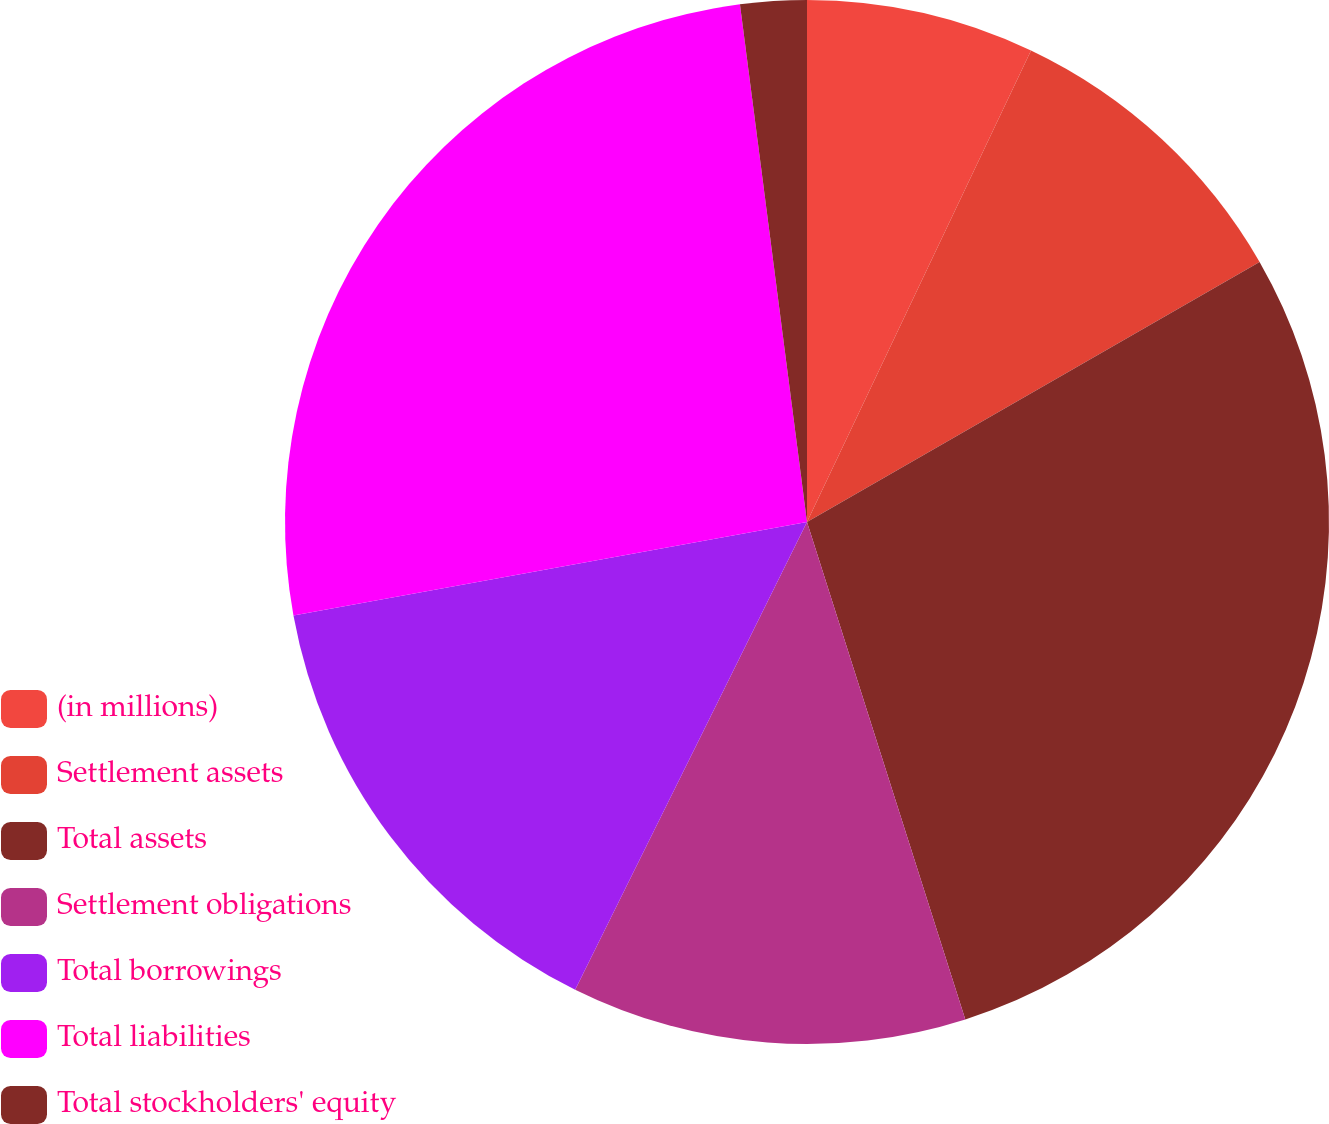Convert chart. <chart><loc_0><loc_0><loc_500><loc_500><pie_chart><fcel>(in millions)<fcel>Settlement assets<fcel>Total assets<fcel>Settlement obligations<fcel>Total borrowings<fcel>Total liabilities<fcel>Total stockholders' equity<nl><fcel>7.06%<fcel>9.64%<fcel>28.4%<fcel>12.23%<fcel>14.81%<fcel>25.82%<fcel>2.05%<nl></chart> 